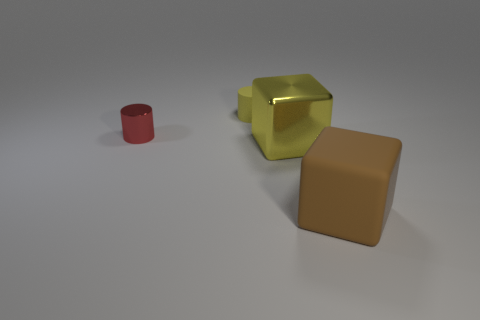What size is the rubber object that is the same color as the big metal thing?
Provide a short and direct response. Small. There is a metallic thing on the left side of the yellow matte thing; does it have the same size as the rubber thing that is left of the brown matte thing?
Provide a short and direct response. Yes. How big is the metallic object that is in front of the red shiny object?
Keep it short and to the point. Large. There is a object that is the same color as the matte cylinder; what is it made of?
Provide a short and direct response. Metal. There is a rubber cylinder that is the same size as the red shiny cylinder; what color is it?
Provide a succinct answer. Yellow. Is the yellow matte thing the same size as the metal cube?
Make the answer very short. No. There is a object that is both behind the rubber block and in front of the tiny red shiny thing; what is its size?
Make the answer very short. Large. How many rubber things are large yellow spheres or large brown cubes?
Give a very brief answer. 1. Is the number of small objects to the left of the tiny yellow object greater than the number of small matte spheres?
Provide a succinct answer. Yes. What material is the yellow object that is in front of the tiny metal cylinder?
Offer a very short reply. Metal. 